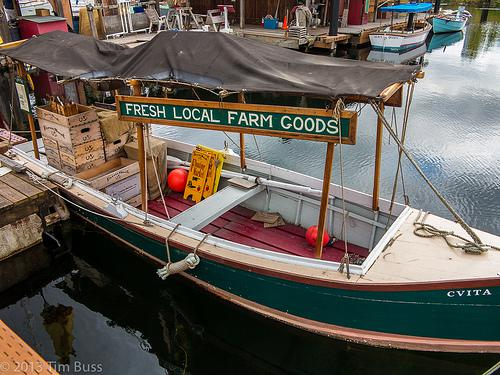Question: what color is the floor?
Choices:
A. Mauve.
B. Blue.
C. White.
D. Black.
Answer with the letter. Answer: A Question: how does the water look?
Choices:
A. Dirty.
B. Calm.
C. Muddy.
D. Clean.
Answer with the letter. Answer: B Question: when was the photo taken?
Choices:
A. Yesterday.
B. Today.
C. A year ago.
D. In the past.
Answer with the letter. Answer: A 